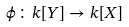Convert formula to latex. <formula><loc_0><loc_0><loc_500><loc_500>\phi \colon k [ Y ] \to k [ X ]</formula> 